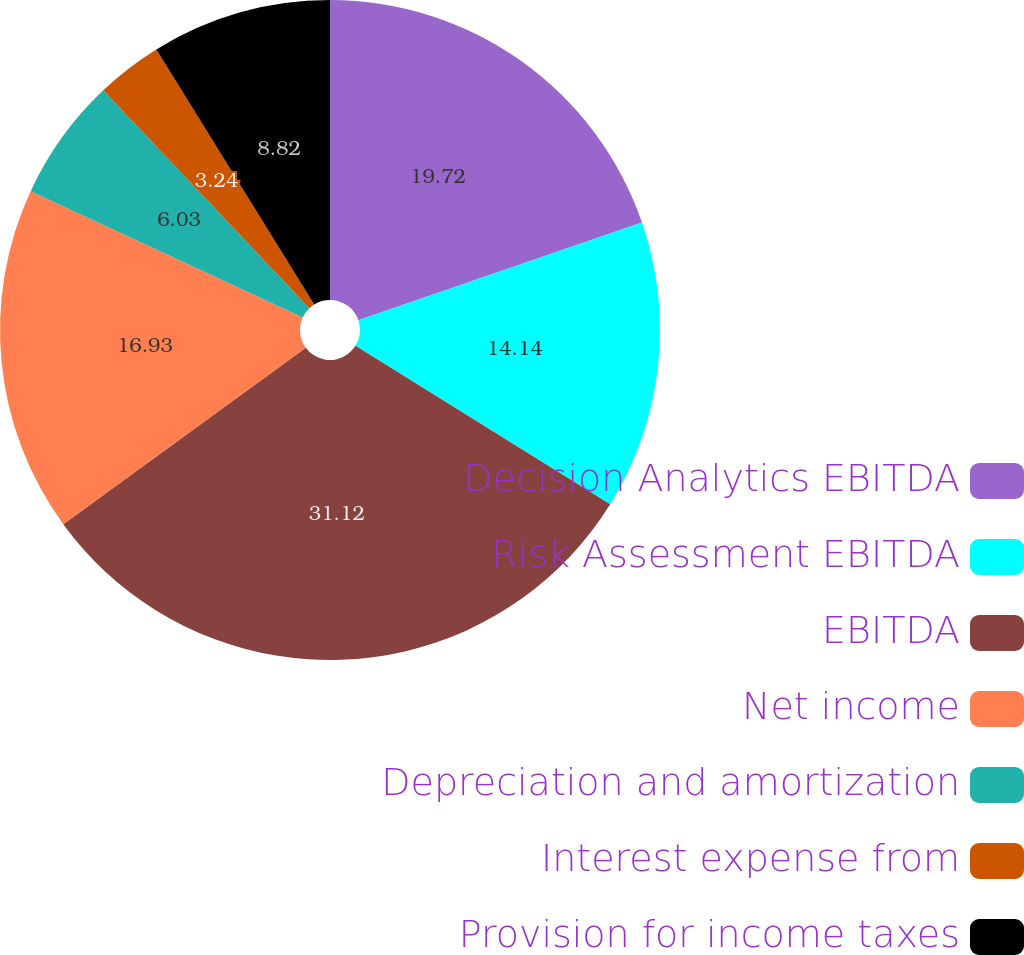Convert chart to OTSL. <chart><loc_0><loc_0><loc_500><loc_500><pie_chart><fcel>Decision Analytics EBITDA<fcel>Risk Assessment EBITDA<fcel>EBITDA<fcel>Net income<fcel>Depreciation and amortization<fcel>Interest expense from<fcel>Provision for income taxes<nl><fcel>19.72%<fcel>14.14%<fcel>31.12%<fcel>16.93%<fcel>6.03%<fcel>3.24%<fcel>8.82%<nl></chart> 